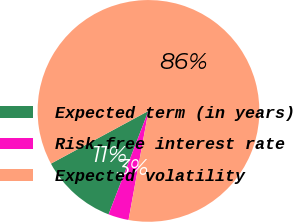Convert chart. <chart><loc_0><loc_0><loc_500><loc_500><pie_chart><fcel>Expected term (in years)<fcel>Risk-free interest rate<fcel>Expected volatility<nl><fcel>11.26%<fcel>2.98%<fcel>85.77%<nl></chart> 